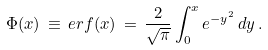<formula> <loc_0><loc_0><loc_500><loc_500>\Phi ( x ) \, \equiv \, e r f ( x ) \, = \, \frac { 2 } { \sqrt { \pi } } \int ^ { x } _ { 0 } e ^ { - y ^ { 2 } } { \, d } y \, .</formula> 